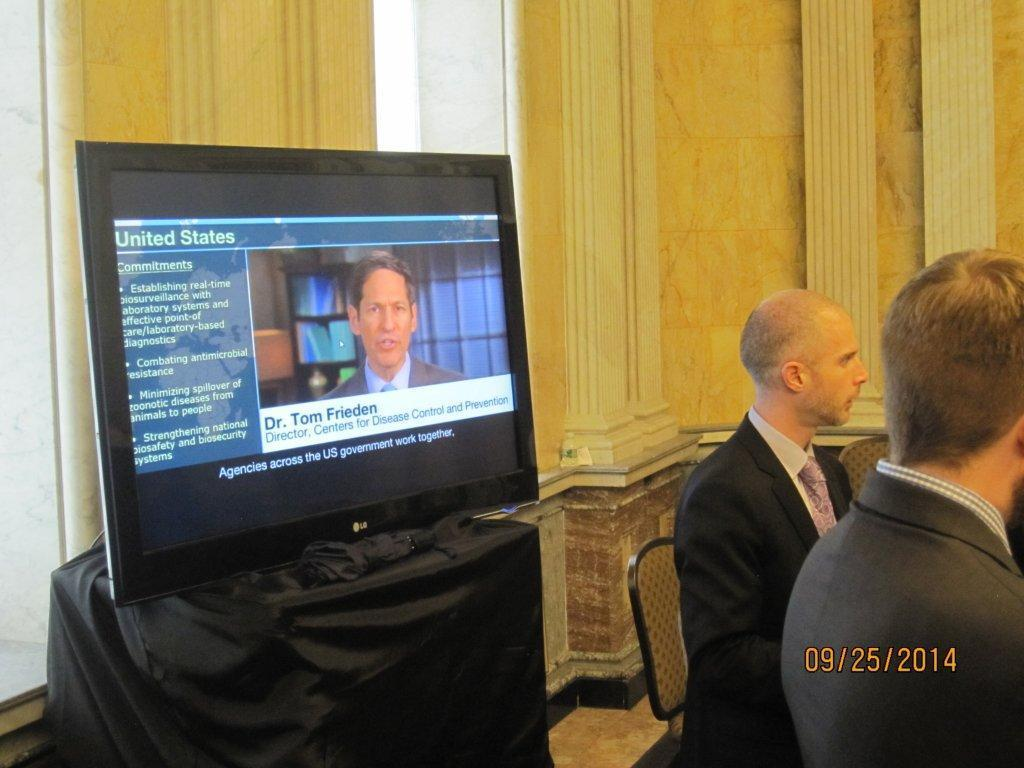<image>
Summarize the visual content of the image. Two men are standing in front of an LG branded television while a dr tom frieden is talking on the screen. 